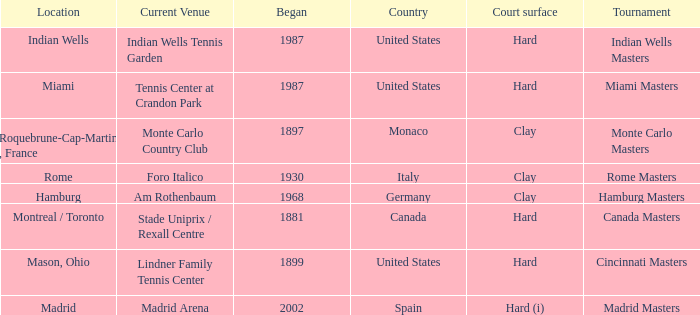What is the current venue for the Miami Masters tournament? Tennis Center at Crandon Park. 